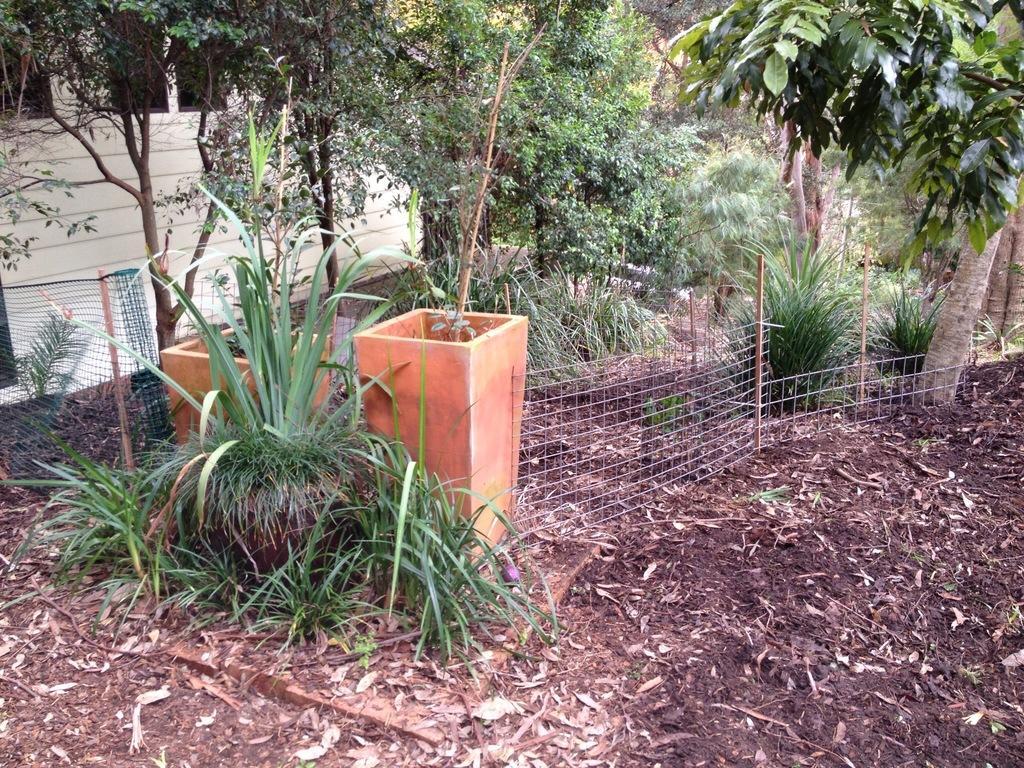Describe this image in one or two sentences. In this image there are two pots in the middle. At the bottom there is ground on which there are dry leaves and soil. In the background there are trees. Beside the pots there is a fence. On the left side there is a wall. 